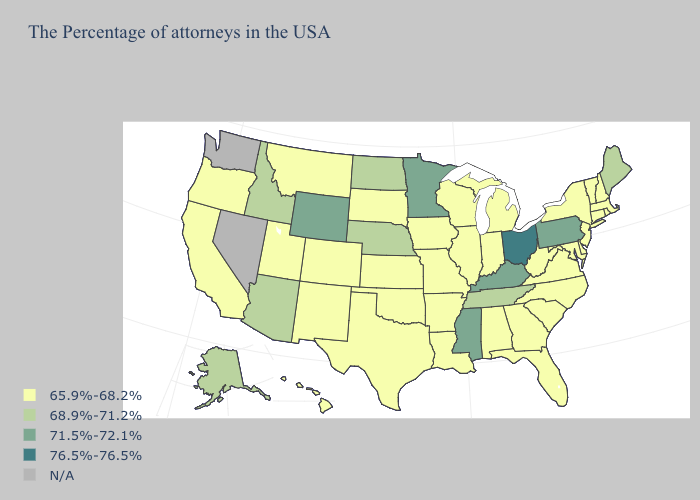What is the lowest value in the USA?
Give a very brief answer. 65.9%-68.2%. What is the lowest value in the USA?
Keep it brief. 65.9%-68.2%. Name the states that have a value in the range 68.9%-71.2%?
Quick response, please. Maine, Tennessee, Nebraska, North Dakota, Arizona, Idaho, Alaska. Which states have the highest value in the USA?
Answer briefly. Ohio. What is the highest value in the USA?
Answer briefly. 76.5%-76.5%. What is the value of Mississippi?
Short answer required. 71.5%-72.1%. What is the value of Delaware?
Concise answer only. 65.9%-68.2%. Name the states that have a value in the range 76.5%-76.5%?
Concise answer only. Ohio. Among the states that border Louisiana , which have the lowest value?
Write a very short answer. Arkansas, Texas. What is the highest value in the South ?
Give a very brief answer. 71.5%-72.1%. Does the map have missing data?
Quick response, please. Yes. Which states hav the highest value in the MidWest?
Give a very brief answer. Ohio. 